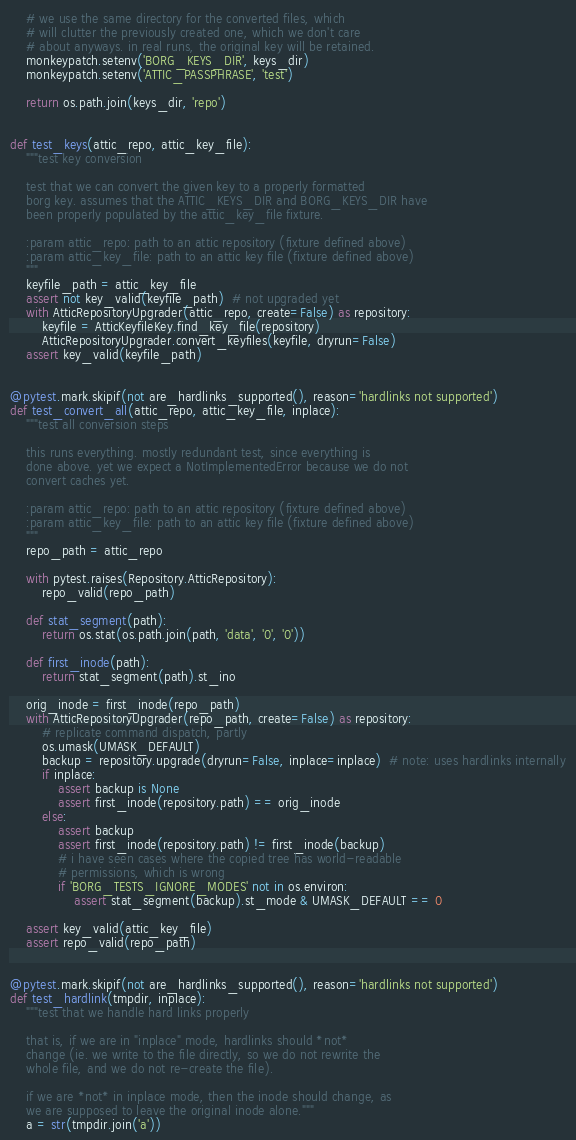<code> <loc_0><loc_0><loc_500><loc_500><_Python_>    # we use the same directory for the converted files, which
    # will clutter the previously created one, which we don't care
    # about anyways. in real runs, the original key will be retained.
    monkeypatch.setenv('BORG_KEYS_DIR', keys_dir)
    monkeypatch.setenv('ATTIC_PASSPHRASE', 'test')

    return os.path.join(keys_dir, 'repo')


def test_keys(attic_repo, attic_key_file):
    """test key conversion

    test that we can convert the given key to a properly formatted
    borg key. assumes that the ATTIC_KEYS_DIR and BORG_KEYS_DIR have
    been properly populated by the attic_key_file fixture.

    :param attic_repo: path to an attic repository (fixture defined above)
    :param attic_key_file: path to an attic key file (fixture defined above)
    """
    keyfile_path = attic_key_file
    assert not key_valid(keyfile_path)  # not upgraded yet
    with AtticRepositoryUpgrader(attic_repo, create=False) as repository:
        keyfile = AtticKeyfileKey.find_key_file(repository)
        AtticRepositoryUpgrader.convert_keyfiles(keyfile, dryrun=False)
    assert key_valid(keyfile_path)


@pytest.mark.skipif(not are_hardlinks_supported(), reason='hardlinks not supported')
def test_convert_all(attic_repo, attic_key_file, inplace):
    """test all conversion steps

    this runs everything. mostly redundant test, since everything is
    done above. yet we expect a NotImplementedError because we do not
    convert caches yet.

    :param attic_repo: path to an attic repository (fixture defined above)
    :param attic_key_file: path to an attic key file (fixture defined above)
    """
    repo_path = attic_repo

    with pytest.raises(Repository.AtticRepository):
        repo_valid(repo_path)

    def stat_segment(path):
        return os.stat(os.path.join(path, 'data', '0', '0'))

    def first_inode(path):
        return stat_segment(path).st_ino

    orig_inode = first_inode(repo_path)
    with AtticRepositoryUpgrader(repo_path, create=False) as repository:
        # replicate command dispatch, partly
        os.umask(UMASK_DEFAULT)
        backup = repository.upgrade(dryrun=False, inplace=inplace)  # note: uses hardlinks internally
        if inplace:
            assert backup is None
            assert first_inode(repository.path) == orig_inode
        else:
            assert backup
            assert first_inode(repository.path) != first_inode(backup)
            # i have seen cases where the copied tree has world-readable
            # permissions, which is wrong
            if 'BORG_TESTS_IGNORE_MODES' not in os.environ:
                assert stat_segment(backup).st_mode & UMASK_DEFAULT == 0

    assert key_valid(attic_key_file)
    assert repo_valid(repo_path)


@pytest.mark.skipif(not are_hardlinks_supported(), reason='hardlinks not supported')
def test_hardlink(tmpdir, inplace):
    """test that we handle hard links properly

    that is, if we are in "inplace" mode, hardlinks should *not*
    change (ie. we write to the file directly, so we do not rewrite the
    whole file, and we do not re-create the file).

    if we are *not* in inplace mode, then the inode should change, as
    we are supposed to leave the original inode alone."""
    a = str(tmpdir.join('a'))</code> 